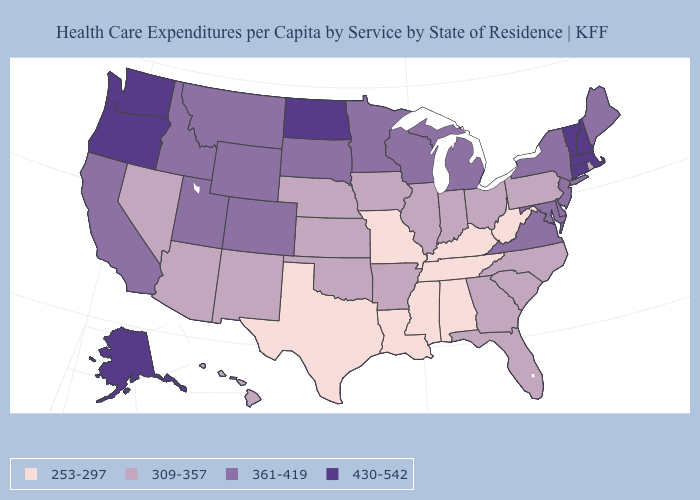What is the highest value in states that border Massachusetts?
Answer briefly. 430-542. Which states have the lowest value in the MidWest?
Concise answer only. Missouri. What is the value of Pennsylvania?
Be succinct. 309-357. Name the states that have a value in the range 309-357?
Write a very short answer. Arizona, Arkansas, Florida, Georgia, Hawaii, Illinois, Indiana, Iowa, Kansas, Nebraska, Nevada, New Mexico, North Carolina, Ohio, Oklahoma, Pennsylvania, Rhode Island, South Carolina. What is the highest value in states that border Ohio?
Keep it brief. 361-419. Name the states that have a value in the range 361-419?
Keep it brief. California, Colorado, Delaware, Idaho, Maine, Maryland, Michigan, Minnesota, Montana, New Jersey, New York, South Dakota, Utah, Virginia, Wisconsin, Wyoming. Does North Dakota have the highest value in the MidWest?
Answer briefly. Yes. Name the states that have a value in the range 309-357?
Give a very brief answer. Arizona, Arkansas, Florida, Georgia, Hawaii, Illinois, Indiana, Iowa, Kansas, Nebraska, Nevada, New Mexico, North Carolina, Ohio, Oklahoma, Pennsylvania, Rhode Island, South Carolina. Which states have the highest value in the USA?
Concise answer only. Alaska, Connecticut, Massachusetts, New Hampshire, North Dakota, Oregon, Vermont, Washington. What is the lowest value in the USA?
Be succinct. 253-297. What is the lowest value in the USA?
Be succinct. 253-297. Among the states that border Oregon , which have the lowest value?
Concise answer only. Nevada. Name the states that have a value in the range 253-297?
Write a very short answer. Alabama, Kentucky, Louisiana, Mississippi, Missouri, Tennessee, Texas, West Virginia. Is the legend a continuous bar?
Concise answer only. No. 